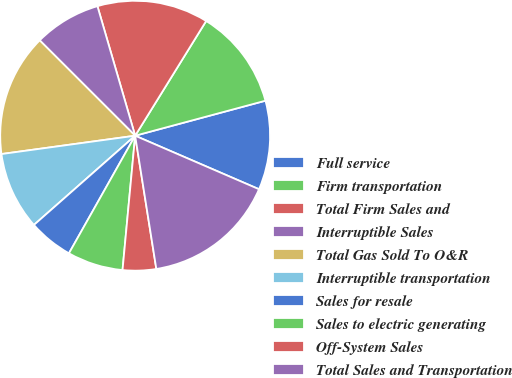Convert chart. <chart><loc_0><loc_0><loc_500><loc_500><pie_chart><fcel>Full service<fcel>Firm transportation<fcel>Total Firm Sales and<fcel>Interruptible Sales<fcel>Total Gas Sold To O&R<fcel>Interruptible transportation<fcel>Sales for resale<fcel>Sales to electric generating<fcel>Off-System Sales<fcel>Total Sales and Transportation<nl><fcel>10.67%<fcel>12.0%<fcel>13.33%<fcel>8.0%<fcel>14.66%<fcel>9.33%<fcel>5.34%<fcel>6.67%<fcel>4.0%<fcel>16.0%<nl></chart> 